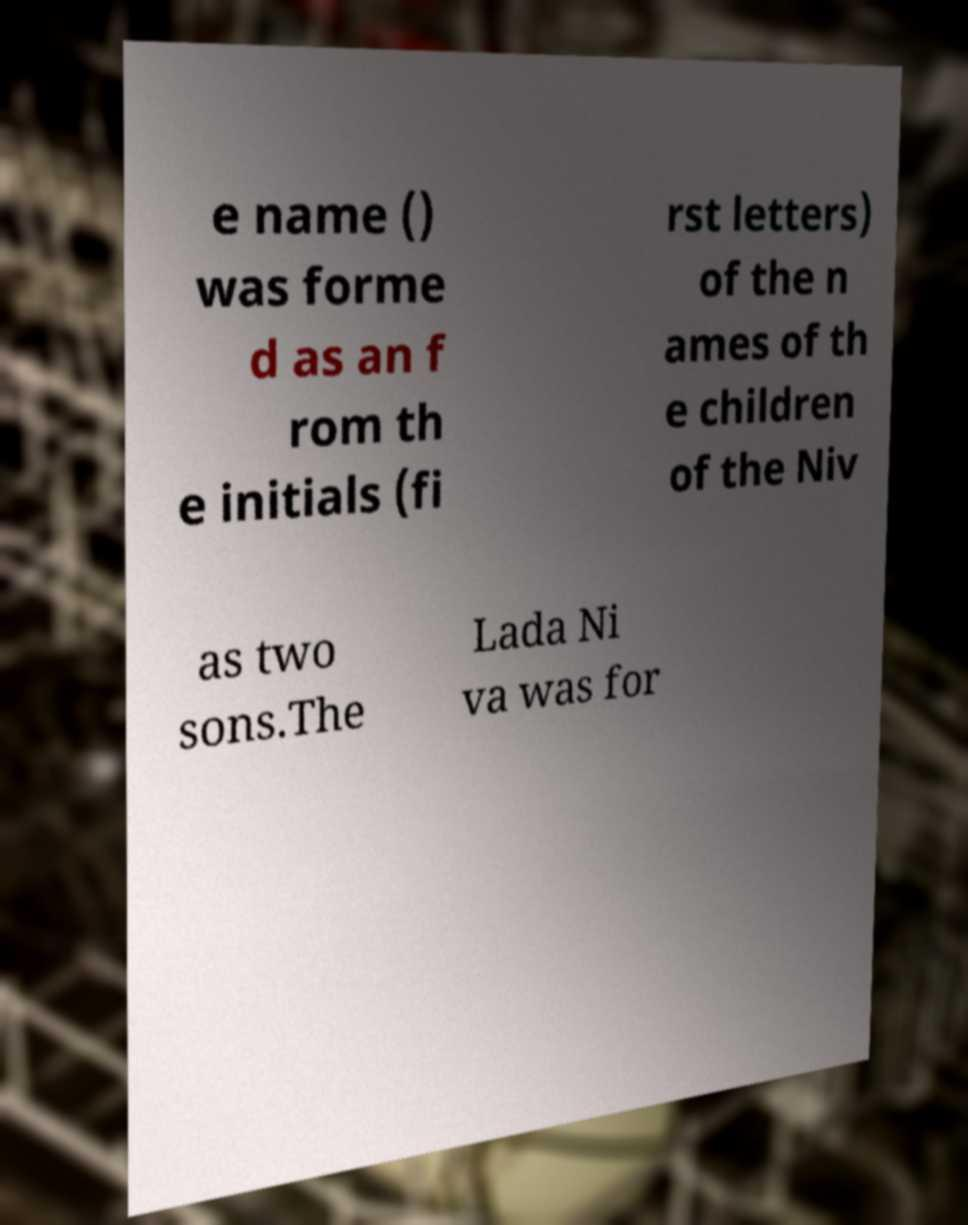There's text embedded in this image that I need extracted. Can you transcribe it verbatim? e name () was forme d as an f rom th e initials (fi rst letters) of the n ames of th e children of the Niv as two sons.The Lada Ni va was for 